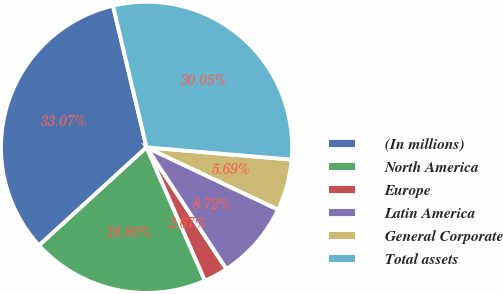Convert chart to OTSL. <chart><loc_0><loc_0><loc_500><loc_500><pie_chart><fcel>(In millions)<fcel>North America<fcel>Europe<fcel>Latin America<fcel>General Corporate<fcel>Total assets<nl><fcel>33.07%<fcel>19.8%<fcel>2.67%<fcel>8.72%<fcel>5.69%<fcel>30.05%<nl></chart> 